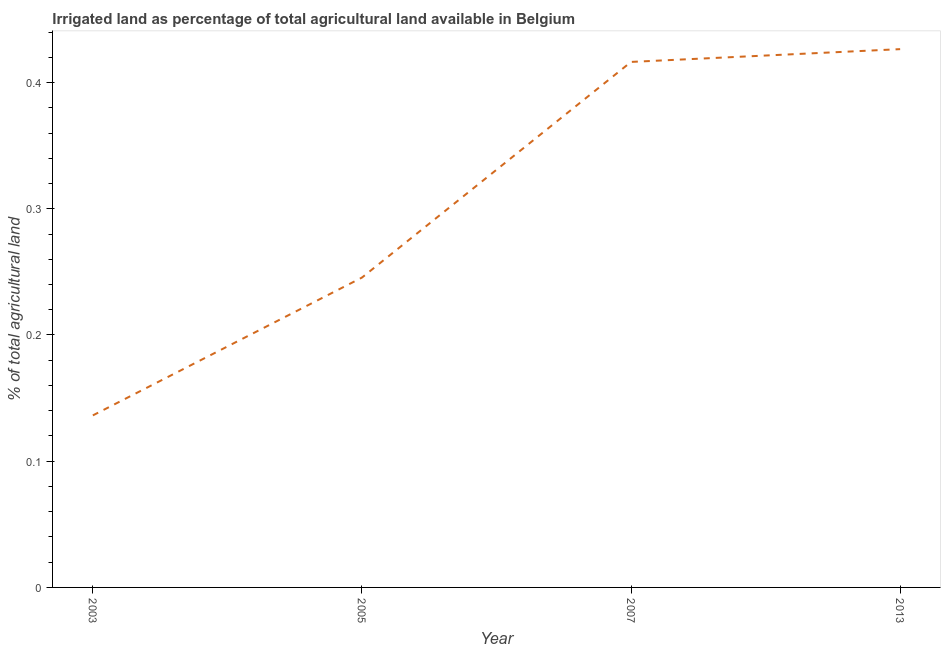What is the percentage of agricultural irrigated land in 2013?
Keep it short and to the point. 0.43. Across all years, what is the maximum percentage of agricultural irrigated land?
Provide a short and direct response. 0.43. Across all years, what is the minimum percentage of agricultural irrigated land?
Give a very brief answer. 0.14. What is the sum of the percentage of agricultural irrigated land?
Ensure brevity in your answer.  1.22. What is the difference between the percentage of agricultural irrigated land in 2005 and 2007?
Ensure brevity in your answer.  -0.17. What is the average percentage of agricultural irrigated land per year?
Provide a succinct answer. 0.31. What is the median percentage of agricultural irrigated land?
Offer a very short reply. 0.33. In how many years, is the percentage of agricultural irrigated land greater than 0.42000000000000004 %?
Your answer should be very brief. 1. Do a majority of the years between 2003 and 2007 (inclusive) have percentage of agricultural irrigated land greater than 0.04 %?
Give a very brief answer. Yes. What is the ratio of the percentage of agricultural irrigated land in 2003 to that in 2007?
Give a very brief answer. 0.33. Is the percentage of agricultural irrigated land in 2003 less than that in 2007?
Provide a short and direct response. Yes. What is the difference between the highest and the second highest percentage of agricultural irrigated land?
Provide a short and direct response. 0.01. What is the difference between the highest and the lowest percentage of agricultural irrigated land?
Offer a very short reply. 0.29. Does the percentage of agricultural irrigated land monotonically increase over the years?
Your answer should be very brief. Yes. How many years are there in the graph?
Give a very brief answer. 4. What is the difference between two consecutive major ticks on the Y-axis?
Offer a very short reply. 0.1. Does the graph contain any zero values?
Offer a terse response. No. Does the graph contain grids?
Ensure brevity in your answer.  No. What is the title of the graph?
Offer a terse response. Irrigated land as percentage of total agricultural land available in Belgium. What is the label or title of the Y-axis?
Provide a succinct answer. % of total agricultural land. What is the % of total agricultural land in 2003?
Provide a short and direct response. 0.14. What is the % of total agricultural land in 2005?
Offer a very short reply. 0.25. What is the % of total agricultural land in 2007?
Provide a short and direct response. 0.42. What is the % of total agricultural land of 2013?
Make the answer very short. 0.43. What is the difference between the % of total agricultural land in 2003 and 2005?
Give a very brief answer. -0.11. What is the difference between the % of total agricultural land in 2003 and 2007?
Offer a very short reply. -0.28. What is the difference between the % of total agricultural land in 2003 and 2013?
Your answer should be compact. -0.29. What is the difference between the % of total agricultural land in 2005 and 2007?
Keep it short and to the point. -0.17. What is the difference between the % of total agricultural land in 2005 and 2013?
Provide a succinct answer. -0.18. What is the difference between the % of total agricultural land in 2007 and 2013?
Your answer should be compact. -0.01. What is the ratio of the % of total agricultural land in 2003 to that in 2005?
Provide a succinct answer. 0.56. What is the ratio of the % of total agricultural land in 2003 to that in 2007?
Provide a succinct answer. 0.33. What is the ratio of the % of total agricultural land in 2003 to that in 2013?
Give a very brief answer. 0.32. What is the ratio of the % of total agricultural land in 2005 to that in 2007?
Your answer should be compact. 0.59. What is the ratio of the % of total agricultural land in 2005 to that in 2013?
Ensure brevity in your answer.  0.58. 